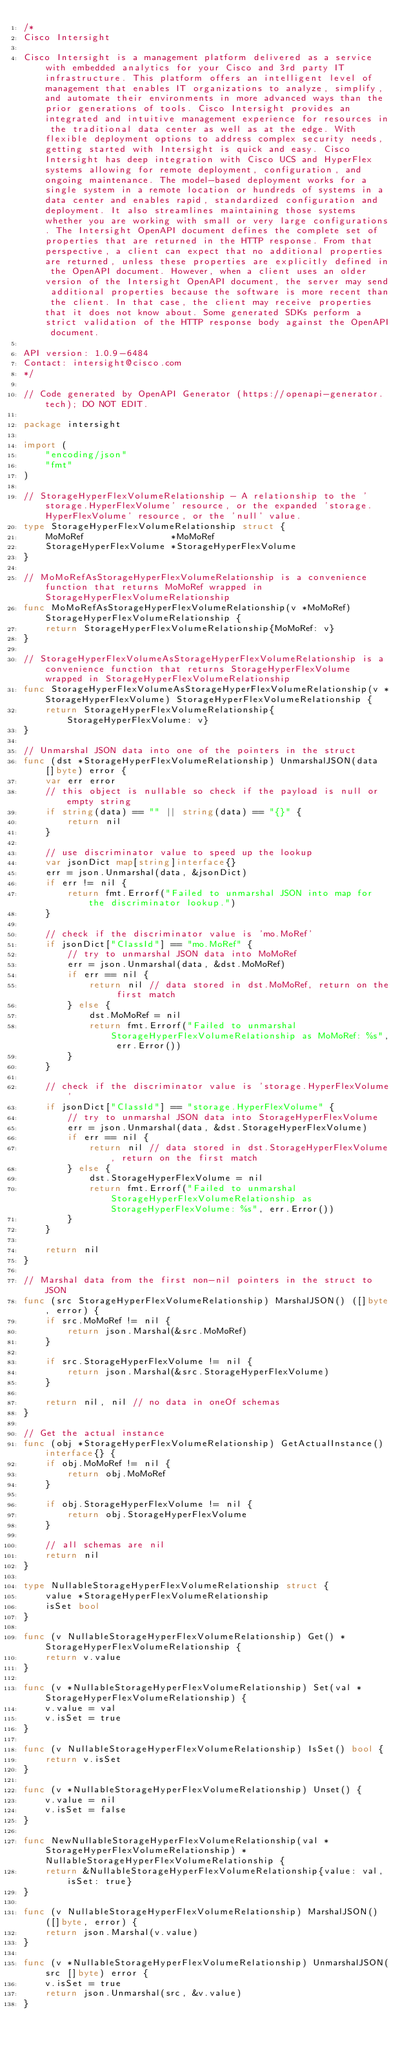<code> <loc_0><loc_0><loc_500><loc_500><_Go_>/*
Cisco Intersight

Cisco Intersight is a management platform delivered as a service with embedded analytics for your Cisco and 3rd party IT infrastructure. This platform offers an intelligent level of management that enables IT organizations to analyze, simplify, and automate their environments in more advanced ways than the prior generations of tools. Cisco Intersight provides an integrated and intuitive management experience for resources in the traditional data center as well as at the edge. With flexible deployment options to address complex security needs, getting started with Intersight is quick and easy. Cisco Intersight has deep integration with Cisco UCS and HyperFlex systems allowing for remote deployment, configuration, and ongoing maintenance. The model-based deployment works for a single system in a remote location or hundreds of systems in a data center and enables rapid, standardized configuration and deployment. It also streamlines maintaining those systems whether you are working with small or very large configurations. The Intersight OpenAPI document defines the complete set of properties that are returned in the HTTP response. From that perspective, a client can expect that no additional properties are returned, unless these properties are explicitly defined in the OpenAPI document. However, when a client uses an older version of the Intersight OpenAPI document, the server may send additional properties because the software is more recent than the client. In that case, the client may receive properties that it does not know about. Some generated SDKs perform a strict validation of the HTTP response body against the OpenAPI document.

API version: 1.0.9-6484
Contact: intersight@cisco.com
*/

// Code generated by OpenAPI Generator (https://openapi-generator.tech); DO NOT EDIT.

package intersight

import (
	"encoding/json"
	"fmt"
)

// StorageHyperFlexVolumeRelationship - A relationship to the 'storage.HyperFlexVolume' resource, or the expanded 'storage.HyperFlexVolume' resource, or the 'null' value.
type StorageHyperFlexVolumeRelationship struct {
	MoMoRef                *MoMoRef
	StorageHyperFlexVolume *StorageHyperFlexVolume
}

// MoMoRefAsStorageHyperFlexVolumeRelationship is a convenience function that returns MoMoRef wrapped in StorageHyperFlexVolumeRelationship
func MoMoRefAsStorageHyperFlexVolumeRelationship(v *MoMoRef) StorageHyperFlexVolumeRelationship {
	return StorageHyperFlexVolumeRelationship{MoMoRef: v}
}

// StorageHyperFlexVolumeAsStorageHyperFlexVolumeRelationship is a convenience function that returns StorageHyperFlexVolume wrapped in StorageHyperFlexVolumeRelationship
func StorageHyperFlexVolumeAsStorageHyperFlexVolumeRelationship(v *StorageHyperFlexVolume) StorageHyperFlexVolumeRelationship {
	return StorageHyperFlexVolumeRelationship{StorageHyperFlexVolume: v}
}

// Unmarshal JSON data into one of the pointers in the struct
func (dst *StorageHyperFlexVolumeRelationship) UnmarshalJSON(data []byte) error {
	var err error
	// this object is nullable so check if the payload is null or empty string
	if string(data) == "" || string(data) == "{}" {
		return nil
	}

	// use discriminator value to speed up the lookup
	var jsonDict map[string]interface{}
	err = json.Unmarshal(data, &jsonDict)
	if err != nil {
		return fmt.Errorf("Failed to unmarshal JSON into map for the discriminator lookup.")
	}

	// check if the discriminator value is 'mo.MoRef'
	if jsonDict["ClassId"] == "mo.MoRef" {
		// try to unmarshal JSON data into MoMoRef
		err = json.Unmarshal(data, &dst.MoMoRef)
		if err == nil {
			return nil // data stored in dst.MoMoRef, return on the first match
		} else {
			dst.MoMoRef = nil
			return fmt.Errorf("Failed to unmarshal StorageHyperFlexVolumeRelationship as MoMoRef: %s", err.Error())
		}
	}

	// check if the discriminator value is 'storage.HyperFlexVolume'
	if jsonDict["ClassId"] == "storage.HyperFlexVolume" {
		// try to unmarshal JSON data into StorageHyperFlexVolume
		err = json.Unmarshal(data, &dst.StorageHyperFlexVolume)
		if err == nil {
			return nil // data stored in dst.StorageHyperFlexVolume, return on the first match
		} else {
			dst.StorageHyperFlexVolume = nil
			return fmt.Errorf("Failed to unmarshal StorageHyperFlexVolumeRelationship as StorageHyperFlexVolume: %s", err.Error())
		}
	}

	return nil
}

// Marshal data from the first non-nil pointers in the struct to JSON
func (src StorageHyperFlexVolumeRelationship) MarshalJSON() ([]byte, error) {
	if src.MoMoRef != nil {
		return json.Marshal(&src.MoMoRef)
	}

	if src.StorageHyperFlexVolume != nil {
		return json.Marshal(&src.StorageHyperFlexVolume)
	}

	return nil, nil // no data in oneOf schemas
}

// Get the actual instance
func (obj *StorageHyperFlexVolumeRelationship) GetActualInstance() interface{} {
	if obj.MoMoRef != nil {
		return obj.MoMoRef
	}

	if obj.StorageHyperFlexVolume != nil {
		return obj.StorageHyperFlexVolume
	}

	// all schemas are nil
	return nil
}

type NullableStorageHyperFlexVolumeRelationship struct {
	value *StorageHyperFlexVolumeRelationship
	isSet bool
}

func (v NullableStorageHyperFlexVolumeRelationship) Get() *StorageHyperFlexVolumeRelationship {
	return v.value
}

func (v *NullableStorageHyperFlexVolumeRelationship) Set(val *StorageHyperFlexVolumeRelationship) {
	v.value = val
	v.isSet = true
}

func (v NullableStorageHyperFlexVolumeRelationship) IsSet() bool {
	return v.isSet
}

func (v *NullableStorageHyperFlexVolumeRelationship) Unset() {
	v.value = nil
	v.isSet = false
}

func NewNullableStorageHyperFlexVolumeRelationship(val *StorageHyperFlexVolumeRelationship) *NullableStorageHyperFlexVolumeRelationship {
	return &NullableStorageHyperFlexVolumeRelationship{value: val, isSet: true}
}

func (v NullableStorageHyperFlexVolumeRelationship) MarshalJSON() ([]byte, error) {
	return json.Marshal(v.value)
}

func (v *NullableStorageHyperFlexVolumeRelationship) UnmarshalJSON(src []byte) error {
	v.isSet = true
	return json.Unmarshal(src, &v.value)
}
</code> 